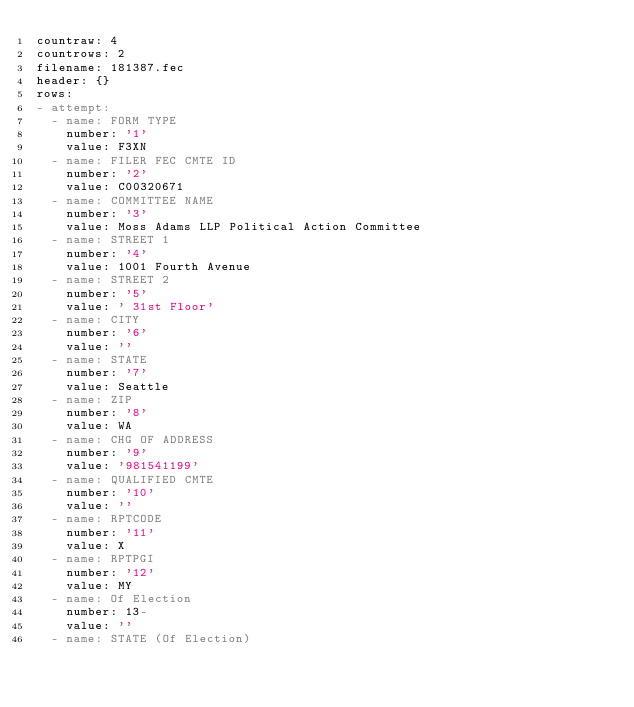<code> <loc_0><loc_0><loc_500><loc_500><_YAML_>countraw: 4
countrows: 2
filename: 181387.fec
header: {}
rows:
- attempt:
  - name: FORM TYPE
    number: '1'
    value: F3XN
  - name: FILER FEC CMTE ID
    number: '2'
    value: C00320671
  - name: COMMITTEE NAME
    number: '3'
    value: Moss Adams LLP Political Action Committee
  - name: STREET 1
    number: '4'
    value: 1001 Fourth Avenue
  - name: STREET 2
    number: '5'
    value: ' 31st Floor'
  - name: CITY
    number: '6'
    value: ''
  - name: STATE
    number: '7'
    value: Seattle
  - name: ZIP
    number: '8'
    value: WA
  - name: CHG OF ADDRESS
    number: '9'
    value: '981541199'
  - name: QUALIFIED CMTE
    number: '10'
    value: ''
  - name: RPTCODE
    number: '11'
    value: X
  - name: RPTPGI
    number: '12'
    value: MY
  - name: Of Election
    number: 13-
    value: ''
  - name: STATE (Of Election)</code> 